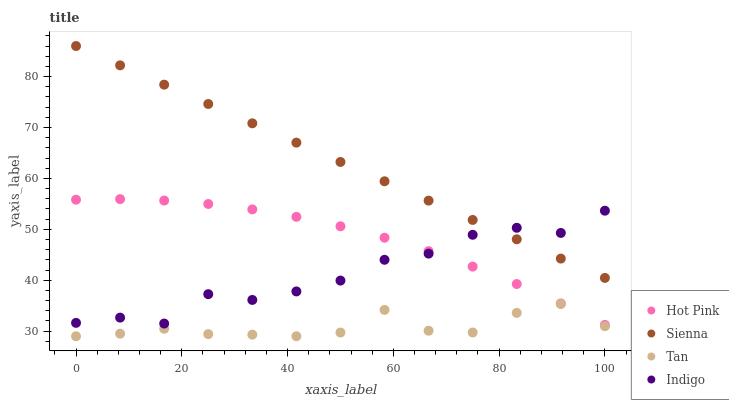Does Tan have the minimum area under the curve?
Answer yes or no. Yes. Does Sienna have the maximum area under the curve?
Answer yes or no. Yes. Does Hot Pink have the minimum area under the curve?
Answer yes or no. No. Does Hot Pink have the maximum area under the curve?
Answer yes or no. No. Is Sienna the smoothest?
Answer yes or no. Yes. Is Indigo the roughest?
Answer yes or no. Yes. Is Tan the smoothest?
Answer yes or no. No. Is Tan the roughest?
Answer yes or no. No. Does Tan have the lowest value?
Answer yes or no. Yes. Does Hot Pink have the lowest value?
Answer yes or no. No. Does Sienna have the highest value?
Answer yes or no. Yes. Does Hot Pink have the highest value?
Answer yes or no. No. Is Tan less than Hot Pink?
Answer yes or no. Yes. Is Hot Pink greater than Tan?
Answer yes or no. Yes. Does Indigo intersect Hot Pink?
Answer yes or no. Yes. Is Indigo less than Hot Pink?
Answer yes or no. No. Is Indigo greater than Hot Pink?
Answer yes or no. No. Does Tan intersect Hot Pink?
Answer yes or no. No. 